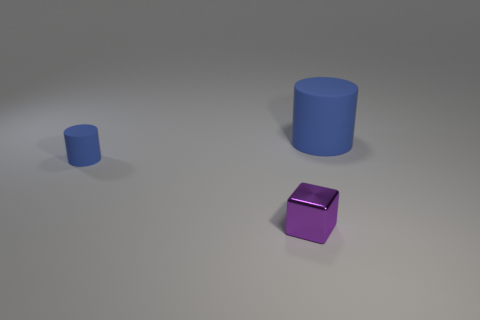Add 2 cubes. How many objects exist? 5 Subtract all cubes. How many objects are left? 2 Subtract 0 purple cylinders. How many objects are left? 3 Subtract 1 blocks. How many blocks are left? 0 Subtract all green cubes. Subtract all purple balls. How many cubes are left? 1 Subtract all gray balls. How many gray cylinders are left? 0 Subtract all big shiny spheres. Subtract all tiny objects. How many objects are left? 1 Add 2 big rubber objects. How many big rubber objects are left? 3 Add 2 tiny cyan metallic cylinders. How many tiny cyan metallic cylinders exist? 2 